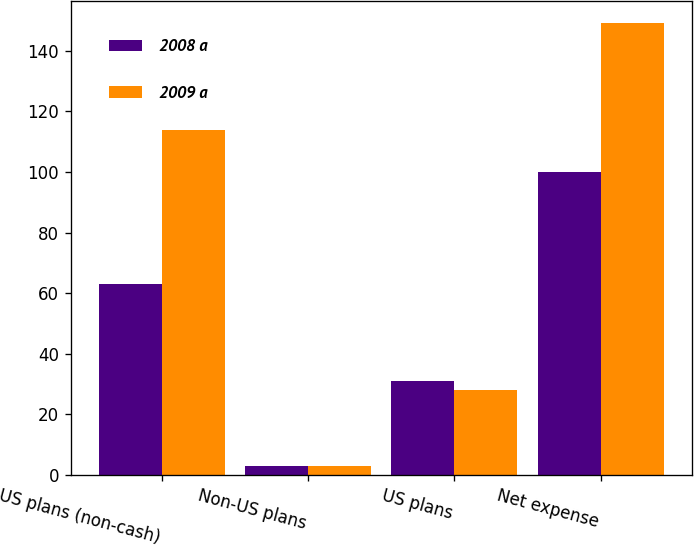<chart> <loc_0><loc_0><loc_500><loc_500><stacked_bar_chart><ecel><fcel>US plans (non-cash)<fcel>Non-US plans<fcel>US plans<fcel>Net expense<nl><fcel>2008 a<fcel>63<fcel>3<fcel>31<fcel>100<nl><fcel>2009 a<fcel>114<fcel>3<fcel>28<fcel>149<nl></chart> 